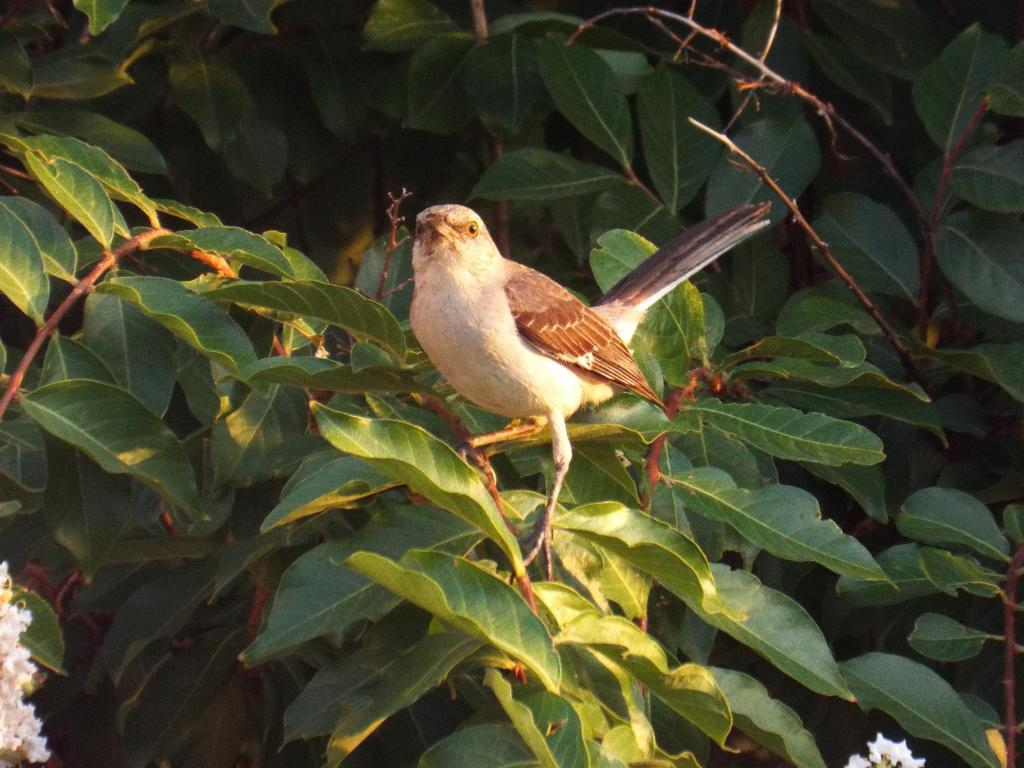What type of animal is in the image? There is a bird in the image. Where is the bird located? The bird is on a plant. What color are the flowers at the bottom of the image? The flowers at the bottom of the image are white. What color are the leaves in the image? The leaves in the image are green. What else in the image has a green color? Green color stems are visible in the image. Can you hear the bird cry in the image? There is no sound in the image, so it is not possible to hear the bird cry. 